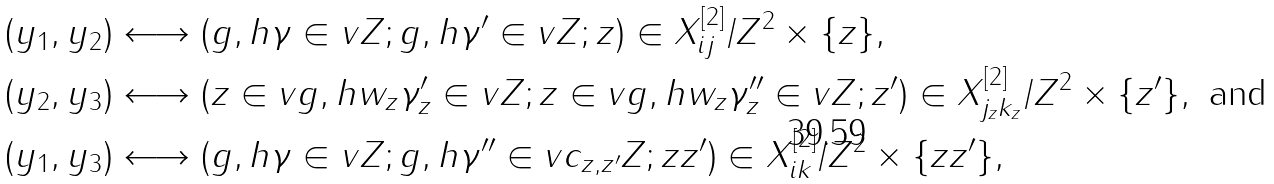Convert formula to latex. <formula><loc_0><loc_0><loc_500><loc_500>( y _ { 1 } , y _ { 2 } ) & \longleftrightarrow ( g , h \gamma \in v Z ; g , h \gamma ^ { \prime } \in v Z ; z ) \in X ^ { [ 2 ] } _ { i j } / Z ^ { 2 } \times \{ z \} , \\ ( y _ { 2 } , y _ { 3 } ) & \longleftrightarrow ( z \in v g , h w _ { z } \gamma _ { z } ^ { \prime } \in v Z ; z \in v g , h w _ { z } \gamma _ { z } ^ { \prime \prime } \in v Z ; z ^ { \prime } ) \in X ^ { [ 2 ] } _ { j _ { z } k _ { z } } / Z ^ { 2 } \times \{ z ^ { \prime } \} , \text { and} \\ ( y _ { 1 } , y _ { 3 } ) & \longleftrightarrow ( g , h \gamma \in v Z ; g , h \gamma ^ { \prime \prime } \in v c _ { z , z ^ { \prime } } Z ; z z ^ { \prime } ) \in X ^ { [ 2 ] } _ { i k } / Z ^ { 2 } \times \{ z z ^ { \prime } \} ,</formula> 